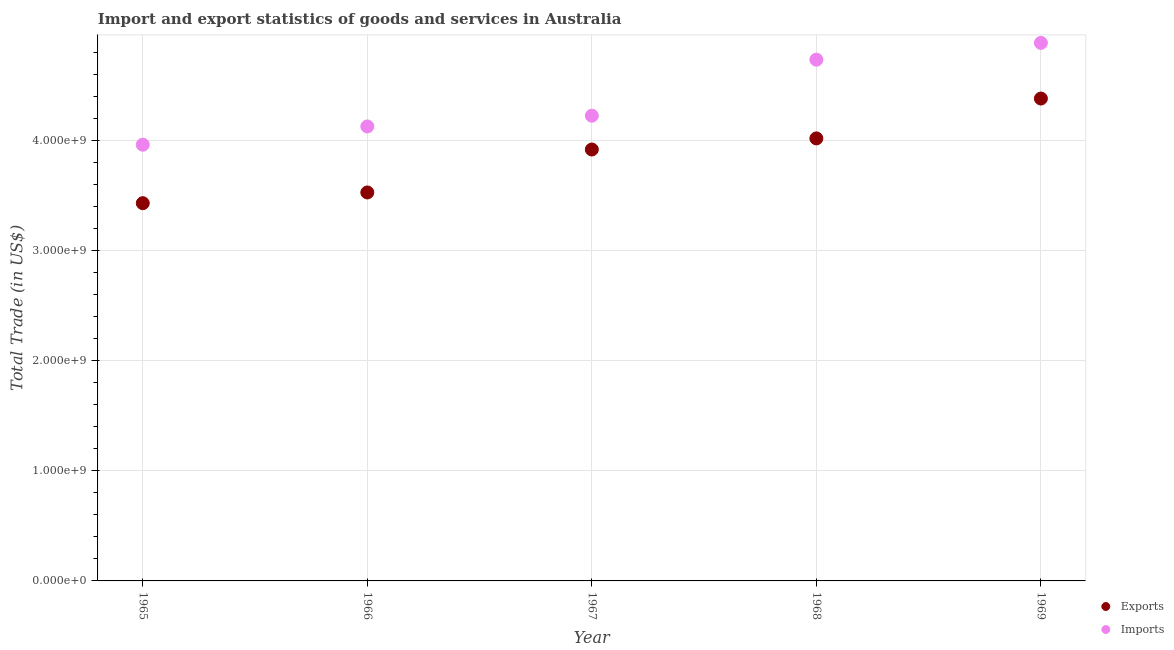How many different coloured dotlines are there?
Offer a terse response. 2. What is the imports of goods and services in 1969?
Offer a very short reply. 4.88e+09. Across all years, what is the maximum export of goods and services?
Offer a terse response. 4.38e+09. Across all years, what is the minimum export of goods and services?
Make the answer very short. 3.43e+09. In which year was the imports of goods and services maximum?
Provide a short and direct response. 1969. In which year was the imports of goods and services minimum?
Keep it short and to the point. 1965. What is the total imports of goods and services in the graph?
Offer a terse response. 2.19e+1. What is the difference between the imports of goods and services in 1965 and that in 1967?
Give a very brief answer. -2.63e+08. What is the difference between the imports of goods and services in 1966 and the export of goods and services in 1965?
Your response must be concise. 6.97e+08. What is the average imports of goods and services per year?
Make the answer very short. 4.38e+09. In the year 1968, what is the difference between the imports of goods and services and export of goods and services?
Offer a terse response. 7.15e+08. In how many years, is the imports of goods and services greater than 600000000 US$?
Provide a short and direct response. 5. What is the ratio of the imports of goods and services in 1967 to that in 1968?
Offer a terse response. 0.89. Is the difference between the export of goods and services in 1966 and 1969 greater than the difference between the imports of goods and services in 1966 and 1969?
Provide a succinct answer. No. What is the difference between the highest and the second highest export of goods and services?
Offer a very short reply. 3.62e+08. What is the difference between the highest and the lowest imports of goods and services?
Give a very brief answer. 9.24e+08. In how many years, is the export of goods and services greater than the average export of goods and services taken over all years?
Your answer should be very brief. 3. Does the export of goods and services monotonically increase over the years?
Give a very brief answer. Yes. Does the graph contain grids?
Give a very brief answer. Yes. Where does the legend appear in the graph?
Offer a very short reply. Bottom right. How many legend labels are there?
Your answer should be very brief. 2. What is the title of the graph?
Provide a succinct answer. Import and export statistics of goods and services in Australia. What is the label or title of the Y-axis?
Make the answer very short. Total Trade (in US$). What is the Total Trade (in US$) in Exports in 1965?
Offer a very short reply. 3.43e+09. What is the Total Trade (in US$) in Imports in 1965?
Provide a succinct answer. 3.96e+09. What is the Total Trade (in US$) in Exports in 1966?
Provide a short and direct response. 3.53e+09. What is the Total Trade (in US$) in Imports in 1966?
Ensure brevity in your answer.  4.12e+09. What is the Total Trade (in US$) in Exports in 1967?
Your answer should be very brief. 3.92e+09. What is the Total Trade (in US$) in Imports in 1967?
Give a very brief answer. 4.22e+09. What is the Total Trade (in US$) of Exports in 1968?
Your answer should be compact. 4.02e+09. What is the Total Trade (in US$) in Imports in 1968?
Offer a terse response. 4.73e+09. What is the Total Trade (in US$) of Exports in 1969?
Make the answer very short. 4.38e+09. What is the Total Trade (in US$) in Imports in 1969?
Give a very brief answer. 4.88e+09. Across all years, what is the maximum Total Trade (in US$) of Exports?
Provide a short and direct response. 4.38e+09. Across all years, what is the maximum Total Trade (in US$) in Imports?
Your response must be concise. 4.88e+09. Across all years, what is the minimum Total Trade (in US$) in Exports?
Keep it short and to the point. 3.43e+09. Across all years, what is the minimum Total Trade (in US$) of Imports?
Offer a very short reply. 3.96e+09. What is the total Total Trade (in US$) in Exports in the graph?
Provide a succinct answer. 1.93e+1. What is the total Total Trade (in US$) in Imports in the graph?
Your answer should be compact. 2.19e+1. What is the difference between the Total Trade (in US$) in Exports in 1965 and that in 1966?
Provide a short and direct response. -9.74e+07. What is the difference between the Total Trade (in US$) in Imports in 1965 and that in 1966?
Your response must be concise. -1.66e+08. What is the difference between the Total Trade (in US$) in Exports in 1965 and that in 1967?
Your answer should be compact. -4.87e+08. What is the difference between the Total Trade (in US$) in Imports in 1965 and that in 1967?
Offer a terse response. -2.63e+08. What is the difference between the Total Trade (in US$) of Exports in 1965 and that in 1968?
Provide a short and direct response. -5.88e+08. What is the difference between the Total Trade (in US$) of Imports in 1965 and that in 1968?
Offer a terse response. -7.72e+08. What is the difference between the Total Trade (in US$) of Exports in 1965 and that in 1969?
Give a very brief answer. -9.50e+08. What is the difference between the Total Trade (in US$) of Imports in 1965 and that in 1969?
Give a very brief answer. -9.24e+08. What is the difference between the Total Trade (in US$) in Exports in 1966 and that in 1967?
Offer a very short reply. -3.90e+08. What is the difference between the Total Trade (in US$) of Imports in 1966 and that in 1967?
Give a very brief answer. -9.74e+07. What is the difference between the Total Trade (in US$) in Exports in 1966 and that in 1968?
Your answer should be very brief. -4.91e+08. What is the difference between the Total Trade (in US$) in Imports in 1966 and that in 1968?
Your answer should be very brief. -6.06e+08. What is the difference between the Total Trade (in US$) in Exports in 1966 and that in 1969?
Your answer should be compact. -8.52e+08. What is the difference between the Total Trade (in US$) in Imports in 1966 and that in 1969?
Your answer should be compact. -7.58e+08. What is the difference between the Total Trade (in US$) of Exports in 1967 and that in 1968?
Provide a short and direct response. -1.01e+08. What is the difference between the Total Trade (in US$) in Imports in 1967 and that in 1968?
Give a very brief answer. -5.08e+08. What is the difference between the Total Trade (in US$) in Exports in 1967 and that in 1969?
Keep it short and to the point. -4.63e+08. What is the difference between the Total Trade (in US$) in Imports in 1967 and that in 1969?
Your answer should be very brief. -6.61e+08. What is the difference between the Total Trade (in US$) in Exports in 1968 and that in 1969?
Your response must be concise. -3.62e+08. What is the difference between the Total Trade (in US$) of Imports in 1968 and that in 1969?
Offer a very short reply. -1.52e+08. What is the difference between the Total Trade (in US$) of Exports in 1965 and the Total Trade (in US$) of Imports in 1966?
Give a very brief answer. -6.97e+08. What is the difference between the Total Trade (in US$) of Exports in 1965 and the Total Trade (in US$) of Imports in 1967?
Make the answer very short. -7.94e+08. What is the difference between the Total Trade (in US$) of Exports in 1965 and the Total Trade (in US$) of Imports in 1968?
Your response must be concise. -1.30e+09. What is the difference between the Total Trade (in US$) in Exports in 1965 and the Total Trade (in US$) in Imports in 1969?
Provide a short and direct response. -1.45e+09. What is the difference between the Total Trade (in US$) of Exports in 1966 and the Total Trade (in US$) of Imports in 1967?
Provide a succinct answer. -6.97e+08. What is the difference between the Total Trade (in US$) in Exports in 1966 and the Total Trade (in US$) in Imports in 1968?
Offer a terse response. -1.21e+09. What is the difference between the Total Trade (in US$) of Exports in 1966 and the Total Trade (in US$) of Imports in 1969?
Make the answer very short. -1.36e+09. What is the difference between the Total Trade (in US$) in Exports in 1967 and the Total Trade (in US$) in Imports in 1968?
Provide a succinct answer. -8.15e+08. What is the difference between the Total Trade (in US$) of Exports in 1967 and the Total Trade (in US$) of Imports in 1969?
Your answer should be compact. -9.68e+08. What is the difference between the Total Trade (in US$) of Exports in 1968 and the Total Trade (in US$) of Imports in 1969?
Your answer should be compact. -8.67e+08. What is the average Total Trade (in US$) of Exports per year?
Ensure brevity in your answer.  3.85e+09. What is the average Total Trade (in US$) of Imports per year?
Offer a terse response. 4.38e+09. In the year 1965, what is the difference between the Total Trade (in US$) in Exports and Total Trade (in US$) in Imports?
Provide a succinct answer. -5.31e+08. In the year 1966, what is the difference between the Total Trade (in US$) in Exports and Total Trade (in US$) in Imports?
Provide a succinct answer. -5.99e+08. In the year 1967, what is the difference between the Total Trade (in US$) of Exports and Total Trade (in US$) of Imports?
Offer a very short reply. -3.07e+08. In the year 1968, what is the difference between the Total Trade (in US$) of Exports and Total Trade (in US$) of Imports?
Keep it short and to the point. -7.15e+08. In the year 1969, what is the difference between the Total Trade (in US$) in Exports and Total Trade (in US$) in Imports?
Your answer should be very brief. -5.05e+08. What is the ratio of the Total Trade (in US$) in Exports in 1965 to that in 1966?
Your answer should be very brief. 0.97. What is the ratio of the Total Trade (in US$) in Imports in 1965 to that in 1966?
Provide a short and direct response. 0.96. What is the ratio of the Total Trade (in US$) of Exports in 1965 to that in 1967?
Make the answer very short. 0.88. What is the ratio of the Total Trade (in US$) of Imports in 1965 to that in 1967?
Your answer should be very brief. 0.94. What is the ratio of the Total Trade (in US$) of Exports in 1965 to that in 1968?
Offer a terse response. 0.85. What is the ratio of the Total Trade (in US$) of Imports in 1965 to that in 1968?
Your response must be concise. 0.84. What is the ratio of the Total Trade (in US$) of Exports in 1965 to that in 1969?
Your response must be concise. 0.78. What is the ratio of the Total Trade (in US$) of Imports in 1965 to that in 1969?
Your response must be concise. 0.81. What is the ratio of the Total Trade (in US$) in Exports in 1966 to that in 1967?
Your response must be concise. 0.9. What is the ratio of the Total Trade (in US$) in Imports in 1966 to that in 1967?
Give a very brief answer. 0.98. What is the ratio of the Total Trade (in US$) of Exports in 1966 to that in 1968?
Provide a short and direct response. 0.88. What is the ratio of the Total Trade (in US$) of Imports in 1966 to that in 1968?
Give a very brief answer. 0.87. What is the ratio of the Total Trade (in US$) in Exports in 1966 to that in 1969?
Your response must be concise. 0.81. What is the ratio of the Total Trade (in US$) of Imports in 1966 to that in 1969?
Your response must be concise. 0.84. What is the ratio of the Total Trade (in US$) in Exports in 1967 to that in 1968?
Give a very brief answer. 0.97. What is the ratio of the Total Trade (in US$) of Imports in 1967 to that in 1968?
Your answer should be compact. 0.89. What is the ratio of the Total Trade (in US$) of Exports in 1967 to that in 1969?
Keep it short and to the point. 0.89. What is the ratio of the Total Trade (in US$) of Imports in 1967 to that in 1969?
Give a very brief answer. 0.86. What is the ratio of the Total Trade (in US$) in Exports in 1968 to that in 1969?
Provide a succinct answer. 0.92. What is the ratio of the Total Trade (in US$) in Imports in 1968 to that in 1969?
Keep it short and to the point. 0.97. What is the difference between the highest and the second highest Total Trade (in US$) in Exports?
Your answer should be compact. 3.62e+08. What is the difference between the highest and the second highest Total Trade (in US$) in Imports?
Your response must be concise. 1.52e+08. What is the difference between the highest and the lowest Total Trade (in US$) of Exports?
Offer a very short reply. 9.50e+08. What is the difference between the highest and the lowest Total Trade (in US$) of Imports?
Give a very brief answer. 9.24e+08. 